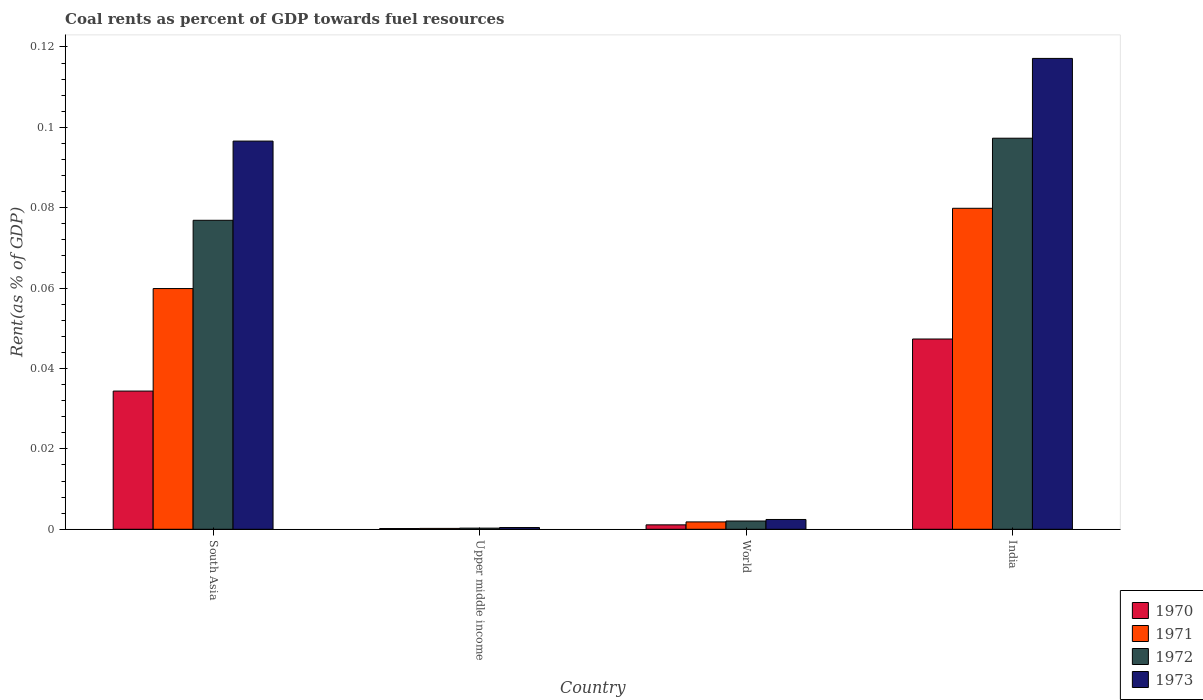How many different coloured bars are there?
Make the answer very short. 4. How many groups of bars are there?
Keep it short and to the point. 4. How many bars are there on the 3rd tick from the left?
Give a very brief answer. 4. How many bars are there on the 2nd tick from the right?
Your answer should be very brief. 4. What is the label of the 2nd group of bars from the left?
Give a very brief answer. Upper middle income. What is the coal rent in 1970 in World?
Offer a very short reply. 0. Across all countries, what is the maximum coal rent in 1971?
Your answer should be compact. 0.08. Across all countries, what is the minimum coal rent in 1971?
Your response must be concise. 0. In which country was the coal rent in 1972 maximum?
Ensure brevity in your answer.  India. In which country was the coal rent in 1972 minimum?
Keep it short and to the point. Upper middle income. What is the total coal rent in 1973 in the graph?
Make the answer very short. 0.22. What is the difference between the coal rent in 1971 in South Asia and that in World?
Offer a very short reply. 0.06. What is the difference between the coal rent in 1970 in Upper middle income and the coal rent in 1973 in World?
Offer a very short reply. -0. What is the average coal rent in 1973 per country?
Give a very brief answer. 0.05. What is the difference between the coal rent of/in 1972 and coal rent of/in 1971 in World?
Ensure brevity in your answer.  0. In how many countries, is the coal rent in 1971 greater than 0.096 %?
Your answer should be very brief. 0. What is the ratio of the coal rent in 1972 in South Asia to that in World?
Provide a short and direct response. 37.41. Is the difference between the coal rent in 1972 in India and World greater than the difference between the coal rent in 1971 in India and World?
Ensure brevity in your answer.  Yes. What is the difference between the highest and the second highest coal rent in 1970?
Your answer should be very brief. 0.01. What is the difference between the highest and the lowest coal rent in 1970?
Provide a succinct answer. 0.05. Is the sum of the coal rent in 1970 in India and World greater than the maximum coal rent in 1972 across all countries?
Provide a succinct answer. No. What does the 4th bar from the left in Upper middle income represents?
Keep it short and to the point. 1973. Is it the case that in every country, the sum of the coal rent in 1970 and coal rent in 1971 is greater than the coal rent in 1973?
Make the answer very short. No. How many bars are there?
Offer a very short reply. 16. Are all the bars in the graph horizontal?
Keep it short and to the point. No. What is the difference between two consecutive major ticks on the Y-axis?
Make the answer very short. 0.02. Are the values on the major ticks of Y-axis written in scientific E-notation?
Provide a succinct answer. No. Does the graph contain any zero values?
Your response must be concise. No. Where does the legend appear in the graph?
Provide a short and direct response. Bottom right. How many legend labels are there?
Provide a succinct answer. 4. What is the title of the graph?
Offer a very short reply. Coal rents as percent of GDP towards fuel resources. What is the label or title of the X-axis?
Keep it short and to the point. Country. What is the label or title of the Y-axis?
Keep it short and to the point. Rent(as % of GDP). What is the Rent(as % of GDP) in 1970 in South Asia?
Your response must be concise. 0.03. What is the Rent(as % of GDP) of 1971 in South Asia?
Keep it short and to the point. 0.06. What is the Rent(as % of GDP) of 1972 in South Asia?
Make the answer very short. 0.08. What is the Rent(as % of GDP) of 1973 in South Asia?
Offer a terse response. 0.1. What is the Rent(as % of GDP) in 1970 in Upper middle income?
Your answer should be compact. 0. What is the Rent(as % of GDP) of 1971 in Upper middle income?
Your response must be concise. 0. What is the Rent(as % of GDP) in 1972 in Upper middle income?
Your response must be concise. 0. What is the Rent(as % of GDP) in 1973 in Upper middle income?
Provide a short and direct response. 0. What is the Rent(as % of GDP) in 1970 in World?
Your answer should be compact. 0. What is the Rent(as % of GDP) of 1971 in World?
Offer a terse response. 0. What is the Rent(as % of GDP) in 1972 in World?
Offer a terse response. 0. What is the Rent(as % of GDP) of 1973 in World?
Your response must be concise. 0. What is the Rent(as % of GDP) in 1970 in India?
Offer a very short reply. 0.05. What is the Rent(as % of GDP) of 1971 in India?
Your answer should be compact. 0.08. What is the Rent(as % of GDP) of 1972 in India?
Your response must be concise. 0.1. What is the Rent(as % of GDP) in 1973 in India?
Offer a terse response. 0.12. Across all countries, what is the maximum Rent(as % of GDP) of 1970?
Make the answer very short. 0.05. Across all countries, what is the maximum Rent(as % of GDP) in 1971?
Ensure brevity in your answer.  0.08. Across all countries, what is the maximum Rent(as % of GDP) in 1972?
Ensure brevity in your answer.  0.1. Across all countries, what is the maximum Rent(as % of GDP) of 1973?
Keep it short and to the point. 0.12. Across all countries, what is the minimum Rent(as % of GDP) in 1970?
Provide a short and direct response. 0. Across all countries, what is the minimum Rent(as % of GDP) in 1971?
Provide a short and direct response. 0. Across all countries, what is the minimum Rent(as % of GDP) of 1972?
Ensure brevity in your answer.  0. Across all countries, what is the minimum Rent(as % of GDP) of 1973?
Give a very brief answer. 0. What is the total Rent(as % of GDP) in 1970 in the graph?
Give a very brief answer. 0.08. What is the total Rent(as % of GDP) of 1971 in the graph?
Your answer should be very brief. 0.14. What is the total Rent(as % of GDP) of 1972 in the graph?
Offer a very short reply. 0.18. What is the total Rent(as % of GDP) of 1973 in the graph?
Keep it short and to the point. 0.22. What is the difference between the Rent(as % of GDP) of 1970 in South Asia and that in Upper middle income?
Keep it short and to the point. 0.03. What is the difference between the Rent(as % of GDP) of 1971 in South Asia and that in Upper middle income?
Your answer should be very brief. 0.06. What is the difference between the Rent(as % of GDP) of 1972 in South Asia and that in Upper middle income?
Make the answer very short. 0.08. What is the difference between the Rent(as % of GDP) of 1973 in South Asia and that in Upper middle income?
Ensure brevity in your answer.  0.1. What is the difference between the Rent(as % of GDP) in 1971 in South Asia and that in World?
Your response must be concise. 0.06. What is the difference between the Rent(as % of GDP) of 1972 in South Asia and that in World?
Ensure brevity in your answer.  0.07. What is the difference between the Rent(as % of GDP) of 1973 in South Asia and that in World?
Provide a short and direct response. 0.09. What is the difference between the Rent(as % of GDP) in 1970 in South Asia and that in India?
Your answer should be very brief. -0.01. What is the difference between the Rent(as % of GDP) of 1971 in South Asia and that in India?
Keep it short and to the point. -0.02. What is the difference between the Rent(as % of GDP) of 1972 in South Asia and that in India?
Make the answer very short. -0.02. What is the difference between the Rent(as % of GDP) in 1973 in South Asia and that in India?
Your response must be concise. -0.02. What is the difference between the Rent(as % of GDP) of 1970 in Upper middle income and that in World?
Give a very brief answer. -0. What is the difference between the Rent(as % of GDP) of 1971 in Upper middle income and that in World?
Give a very brief answer. -0. What is the difference between the Rent(as % of GDP) of 1972 in Upper middle income and that in World?
Provide a succinct answer. -0. What is the difference between the Rent(as % of GDP) in 1973 in Upper middle income and that in World?
Provide a short and direct response. -0. What is the difference between the Rent(as % of GDP) of 1970 in Upper middle income and that in India?
Your answer should be very brief. -0.05. What is the difference between the Rent(as % of GDP) of 1971 in Upper middle income and that in India?
Provide a succinct answer. -0.08. What is the difference between the Rent(as % of GDP) of 1972 in Upper middle income and that in India?
Provide a short and direct response. -0.1. What is the difference between the Rent(as % of GDP) of 1973 in Upper middle income and that in India?
Offer a terse response. -0.12. What is the difference between the Rent(as % of GDP) of 1970 in World and that in India?
Ensure brevity in your answer.  -0.05. What is the difference between the Rent(as % of GDP) of 1971 in World and that in India?
Your response must be concise. -0.08. What is the difference between the Rent(as % of GDP) in 1972 in World and that in India?
Your answer should be compact. -0.1. What is the difference between the Rent(as % of GDP) of 1973 in World and that in India?
Provide a short and direct response. -0.11. What is the difference between the Rent(as % of GDP) of 1970 in South Asia and the Rent(as % of GDP) of 1971 in Upper middle income?
Your response must be concise. 0.03. What is the difference between the Rent(as % of GDP) in 1970 in South Asia and the Rent(as % of GDP) in 1972 in Upper middle income?
Give a very brief answer. 0.03. What is the difference between the Rent(as % of GDP) in 1970 in South Asia and the Rent(as % of GDP) in 1973 in Upper middle income?
Your response must be concise. 0.03. What is the difference between the Rent(as % of GDP) of 1971 in South Asia and the Rent(as % of GDP) of 1972 in Upper middle income?
Your answer should be compact. 0.06. What is the difference between the Rent(as % of GDP) in 1971 in South Asia and the Rent(as % of GDP) in 1973 in Upper middle income?
Keep it short and to the point. 0.06. What is the difference between the Rent(as % of GDP) of 1972 in South Asia and the Rent(as % of GDP) of 1973 in Upper middle income?
Make the answer very short. 0.08. What is the difference between the Rent(as % of GDP) of 1970 in South Asia and the Rent(as % of GDP) of 1971 in World?
Your response must be concise. 0.03. What is the difference between the Rent(as % of GDP) in 1970 in South Asia and the Rent(as % of GDP) in 1972 in World?
Ensure brevity in your answer.  0.03. What is the difference between the Rent(as % of GDP) of 1970 in South Asia and the Rent(as % of GDP) of 1973 in World?
Offer a very short reply. 0.03. What is the difference between the Rent(as % of GDP) of 1971 in South Asia and the Rent(as % of GDP) of 1972 in World?
Your answer should be compact. 0.06. What is the difference between the Rent(as % of GDP) of 1971 in South Asia and the Rent(as % of GDP) of 1973 in World?
Your answer should be compact. 0.06. What is the difference between the Rent(as % of GDP) in 1972 in South Asia and the Rent(as % of GDP) in 1973 in World?
Your response must be concise. 0.07. What is the difference between the Rent(as % of GDP) in 1970 in South Asia and the Rent(as % of GDP) in 1971 in India?
Your response must be concise. -0.05. What is the difference between the Rent(as % of GDP) of 1970 in South Asia and the Rent(as % of GDP) of 1972 in India?
Offer a terse response. -0.06. What is the difference between the Rent(as % of GDP) of 1970 in South Asia and the Rent(as % of GDP) of 1973 in India?
Ensure brevity in your answer.  -0.08. What is the difference between the Rent(as % of GDP) in 1971 in South Asia and the Rent(as % of GDP) in 1972 in India?
Your answer should be very brief. -0.04. What is the difference between the Rent(as % of GDP) of 1971 in South Asia and the Rent(as % of GDP) of 1973 in India?
Provide a short and direct response. -0.06. What is the difference between the Rent(as % of GDP) of 1972 in South Asia and the Rent(as % of GDP) of 1973 in India?
Provide a succinct answer. -0.04. What is the difference between the Rent(as % of GDP) of 1970 in Upper middle income and the Rent(as % of GDP) of 1971 in World?
Provide a succinct answer. -0. What is the difference between the Rent(as % of GDP) of 1970 in Upper middle income and the Rent(as % of GDP) of 1972 in World?
Give a very brief answer. -0. What is the difference between the Rent(as % of GDP) in 1970 in Upper middle income and the Rent(as % of GDP) in 1973 in World?
Provide a succinct answer. -0. What is the difference between the Rent(as % of GDP) of 1971 in Upper middle income and the Rent(as % of GDP) of 1972 in World?
Offer a terse response. -0. What is the difference between the Rent(as % of GDP) of 1971 in Upper middle income and the Rent(as % of GDP) of 1973 in World?
Ensure brevity in your answer.  -0. What is the difference between the Rent(as % of GDP) in 1972 in Upper middle income and the Rent(as % of GDP) in 1973 in World?
Provide a short and direct response. -0. What is the difference between the Rent(as % of GDP) of 1970 in Upper middle income and the Rent(as % of GDP) of 1971 in India?
Provide a short and direct response. -0.08. What is the difference between the Rent(as % of GDP) of 1970 in Upper middle income and the Rent(as % of GDP) of 1972 in India?
Offer a terse response. -0.1. What is the difference between the Rent(as % of GDP) in 1970 in Upper middle income and the Rent(as % of GDP) in 1973 in India?
Keep it short and to the point. -0.12. What is the difference between the Rent(as % of GDP) of 1971 in Upper middle income and the Rent(as % of GDP) of 1972 in India?
Your answer should be very brief. -0.1. What is the difference between the Rent(as % of GDP) in 1971 in Upper middle income and the Rent(as % of GDP) in 1973 in India?
Your response must be concise. -0.12. What is the difference between the Rent(as % of GDP) in 1972 in Upper middle income and the Rent(as % of GDP) in 1973 in India?
Give a very brief answer. -0.12. What is the difference between the Rent(as % of GDP) in 1970 in World and the Rent(as % of GDP) in 1971 in India?
Your response must be concise. -0.08. What is the difference between the Rent(as % of GDP) of 1970 in World and the Rent(as % of GDP) of 1972 in India?
Your answer should be very brief. -0.1. What is the difference between the Rent(as % of GDP) in 1970 in World and the Rent(as % of GDP) in 1973 in India?
Provide a succinct answer. -0.12. What is the difference between the Rent(as % of GDP) of 1971 in World and the Rent(as % of GDP) of 1972 in India?
Keep it short and to the point. -0.1. What is the difference between the Rent(as % of GDP) of 1971 in World and the Rent(as % of GDP) of 1973 in India?
Give a very brief answer. -0.12. What is the difference between the Rent(as % of GDP) of 1972 in World and the Rent(as % of GDP) of 1973 in India?
Your answer should be very brief. -0.12. What is the average Rent(as % of GDP) in 1970 per country?
Offer a terse response. 0.02. What is the average Rent(as % of GDP) in 1971 per country?
Provide a short and direct response. 0.04. What is the average Rent(as % of GDP) in 1972 per country?
Offer a terse response. 0.04. What is the average Rent(as % of GDP) of 1973 per country?
Your answer should be very brief. 0.05. What is the difference between the Rent(as % of GDP) of 1970 and Rent(as % of GDP) of 1971 in South Asia?
Keep it short and to the point. -0.03. What is the difference between the Rent(as % of GDP) of 1970 and Rent(as % of GDP) of 1972 in South Asia?
Your answer should be compact. -0.04. What is the difference between the Rent(as % of GDP) in 1970 and Rent(as % of GDP) in 1973 in South Asia?
Your answer should be very brief. -0.06. What is the difference between the Rent(as % of GDP) of 1971 and Rent(as % of GDP) of 1972 in South Asia?
Your answer should be very brief. -0.02. What is the difference between the Rent(as % of GDP) of 1971 and Rent(as % of GDP) of 1973 in South Asia?
Offer a terse response. -0.04. What is the difference between the Rent(as % of GDP) in 1972 and Rent(as % of GDP) in 1973 in South Asia?
Your response must be concise. -0.02. What is the difference between the Rent(as % of GDP) of 1970 and Rent(as % of GDP) of 1971 in Upper middle income?
Ensure brevity in your answer.  -0. What is the difference between the Rent(as % of GDP) of 1970 and Rent(as % of GDP) of 1972 in Upper middle income?
Your answer should be very brief. -0. What is the difference between the Rent(as % of GDP) of 1970 and Rent(as % of GDP) of 1973 in Upper middle income?
Your answer should be compact. -0. What is the difference between the Rent(as % of GDP) in 1971 and Rent(as % of GDP) in 1972 in Upper middle income?
Provide a short and direct response. -0. What is the difference between the Rent(as % of GDP) in 1971 and Rent(as % of GDP) in 1973 in Upper middle income?
Provide a succinct answer. -0. What is the difference between the Rent(as % of GDP) of 1972 and Rent(as % of GDP) of 1973 in Upper middle income?
Offer a terse response. -0. What is the difference between the Rent(as % of GDP) in 1970 and Rent(as % of GDP) in 1971 in World?
Your answer should be very brief. -0. What is the difference between the Rent(as % of GDP) in 1970 and Rent(as % of GDP) in 1972 in World?
Make the answer very short. -0. What is the difference between the Rent(as % of GDP) of 1970 and Rent(as % of GDP) of 1973 in World?
Keep it short and to the point. -0. What is the difference between the Rent(as % of GDP) of 1971 and Rent(as % of GDP) of 1972 in World?
Offer a very short reply. -0. What is the difference between the Rent(as % of GDP) in 1971 and Rent(as % of GDP) in 1973 in World?
Offer a very short reply. -0. What is the difference between the Rent(as % of GDP) of 1972 and Rent(as % of GDP) of 1973 in World?
Give a very brief answer. -0. What is the difference between the Rent(as % of GDP) in 1970 and Rent(as % of GDP) in 1971 in India?
Make the answer very short. -0.03. What is the difference between the Rent(as % of GDP) in 1970 and Rent(as % of GDP) in 1972 in India?
Offer a very short reply. -0.05. What is the difference between the Rent(as % of GDP) of 1970 and Rent(as % of GDP) of 1973 in India?
Keep it short and to the point. -0.07. What is the difference between the Rent(as % of GDP) of 1971 and Rent(as % of GDP) of 1972 in India?
Provide a succinct answer. -0.02. What is the difference between the Rent(as % of GDP) of 1971 and Rent(as % of GDP) of 1973 in India?
Your answer should be very brief. -0.04. What is the difference between the Rent(as % of GDP) in 1972 and Rent(as % of GDP) in 1973 in India?
Your answer should be very brief. -0.02. What is the ratio of the Rent(as % of GDP) of 1970 in South Asia to that in Upper middle income?
Keep it short and to the point. 187.05. What is the ratio of the Rent(as % of GDP) of 1971 in South Asia to that in Upper middle income?
Your response must be concise. 273.74. What is the ratio of the Rent(as % of GDP) of 1972 in South Asia to that in Upper middle income?
Provide a short and direct response. 270.32. What is the ratio of the Rent(as % of GDP) of 1973 in South Asia to that in Upper middle income?
Your response must be concise. 224.18. What is the ratio of the Rent(as % of GDP) of 1970 in South Asia to that in World?
Your answer should be compact. 31.24. What is the ratio of the Rent(as % of GDP) of 1971 in South Asia to that in World?
Offer a terse response. 32.69. What is the ratio of the Rent(as % of GDP) of 1972 in South Asia to that in World?
Provide a succinct answer. 37.41. What is the ratio of the Rent(as % of GDP) of 1973 in South Asia to that in World?
Offer a very short reply. 39.65. What is the ratio of the Rent(as % of GDP) of 1970 in South Asia to that in India?
Offer a terse response. 0.73. What is the ratio of the Rent(as % of GDP) in 1971 in South Asia to that in India?
Make the answer very short. 0.75. What is the ratio of the Rent(as % of GDP) of 1972 in South Asia to that in India?
Your response must be concise. 0.79. What is the ratio of the Rent(as % of GDP) in 1973 in South Asia to that in India?
Make the answer very short. 0.82. What is the ratio of the Rent(as % of GDP) in 1970 in Upper middle income to that in World?
Your answer should be compact. 0.17. What is the ratio of the Rent(as % of GDP) in 1971 in Upper middle income to that in World?
Your answer should be compact. 0.12. What is the ratio of the Rent(as % of GDP) in 1972 in Upper middle income to that in World?
Make the answer very short. 0.14. What is the ratio of the Rent(as % of GDP) in 1973 in Upper middle income to that in World?
Offer a very short reply. 0.18. What is the ratio of the Rent(as % of GDP) of 1970 in Upper middle income to that in India?
Your answer should be very brief. 0. What is the ratio of the Rent(as % of GDP) in 1971 in Upper middle income to that in India?
Your answer should be compact. 0. What is the ratio of the Rent(as % of GDP) in 1972 in Upper middle income to that in India?
Give a very brief answer. 0. What is the ratio of the Rent(as % of GDP) in 1973 in Upper middle income to that in India?
Offer a terse response. 0. What is the ratio of the Rent(as % of GDP) in 1970 in World to that in India?
Keep it short and to the point. 0.02. What is the ratio of the Rent(as % of GDP) in 1971 in World to that in India?
Your response must be concise. 0.02. What is the ratio of the Rent(as % of GDP) in 1972 in World to that in India?
Provide a succinct answer. 0.02. What is the ratio of the Rent(as % of GDP) in 1973 in World to that in India?
Offer a terse response. 0.02. What is the difference between the highest and the second highest Rent(as % of GDP) of 1970?
Ensure brevity in your answer.  0.01. What is the difference between the highest and the second highest Rent(as % of GDP) in 1972?
Give a very brief answer. 0.02. What is the difference between the highest and the second highest Rent(as % of GDP) in 1973?
Your response must be concise. 0.02. What is the difference between the highest and the lowest Rent(as % of GDP) in 1970?
Offer a terse response. 0.05. What is the difference between the highest and the lowest Rent(as % of GDP) in 1971?
Your answer should be very brief. 0.08. What is the difference between the highest and the lowest Rent(as % of GDP) of 1972?
Provide a succinct answer. 0.1. What is the difference between the highest and the lowest Rent(as % of GDP) of 1973?
Provide a short and direct response. 0.12. 